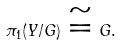<formula> <loc_0><loc_0><loc_500><loc_500>\pi _ { 1 } ( Y / G ) \cong G .</formula> 